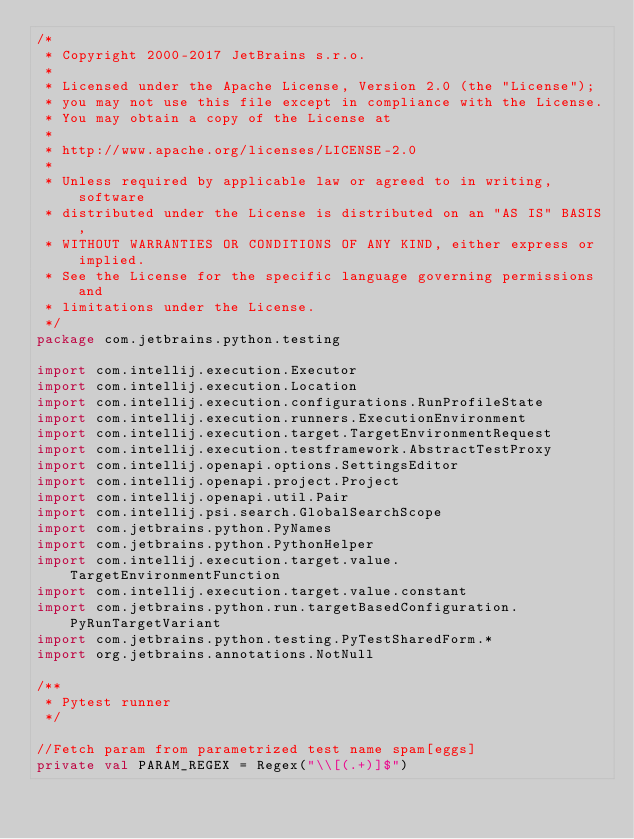Convert code to text. <code><loc_0><loc_0><loc_500><loc_500><_Kotlin_>/*
 * Copyright 2000-2017 JetBrains s.r.o.
 *
 * Licensed under the Apache License, Version 2.0 (the "License");
 * you may not use this file except in compliance with the License.
 * You may obtain a copy of the License at
 *
 * http://www.apache.org/licenses/LICENSE-2.0
 *
 * Unless required by applicable law or agreed to in writing, software
 * distributed under the License is distributed on an "AS IS" BASIS,
 * WITHOUT WARRANTIES OR CONDITIONS OF ANY KIND, either express or implied.
 * See the License for the specific language governing permissions and
 * limitations under the License.
 */
package com.jetbrains.python.testing

import com.intellij.execution.Executor
import com.intellij.execution.Location
import com.intellij.execution.configurations.RunProfileState
import com.intellij.execution.runners.ExecutionEnvironment
import com.intellij.execution.target.TargetEnvironmentRequest
import com.intellij.execution.testframework.AbstractTestProxy
import com.intellij.openapi.options.SettingsEditor
import com.intellij.openapi.project.Project
import com.intellij.openapi.util.Pair
import com.intellij.psi.search.GlobalSearchScope
import com.jetbrains.python.PyNames
import com.jetbrains.python.PythonHelper
import com.intellij.execution.target.value.TargetEnvironmentFunction
import com.intellij.execution.target.value.constant
import com.jetbrains.python.run.targetBasedConfiguration.PyRunTargetVariant
import com.jetbrains.python.testing.PyTestSharedForm.*
import org.jetbrains.annotations.NotNull

/**
 * Pytest runner
 */

//Fetch param from parametrized test name spam[eggs]
private val PARAM_REGEX = Regex("\\[(.+)]$")
</code> 